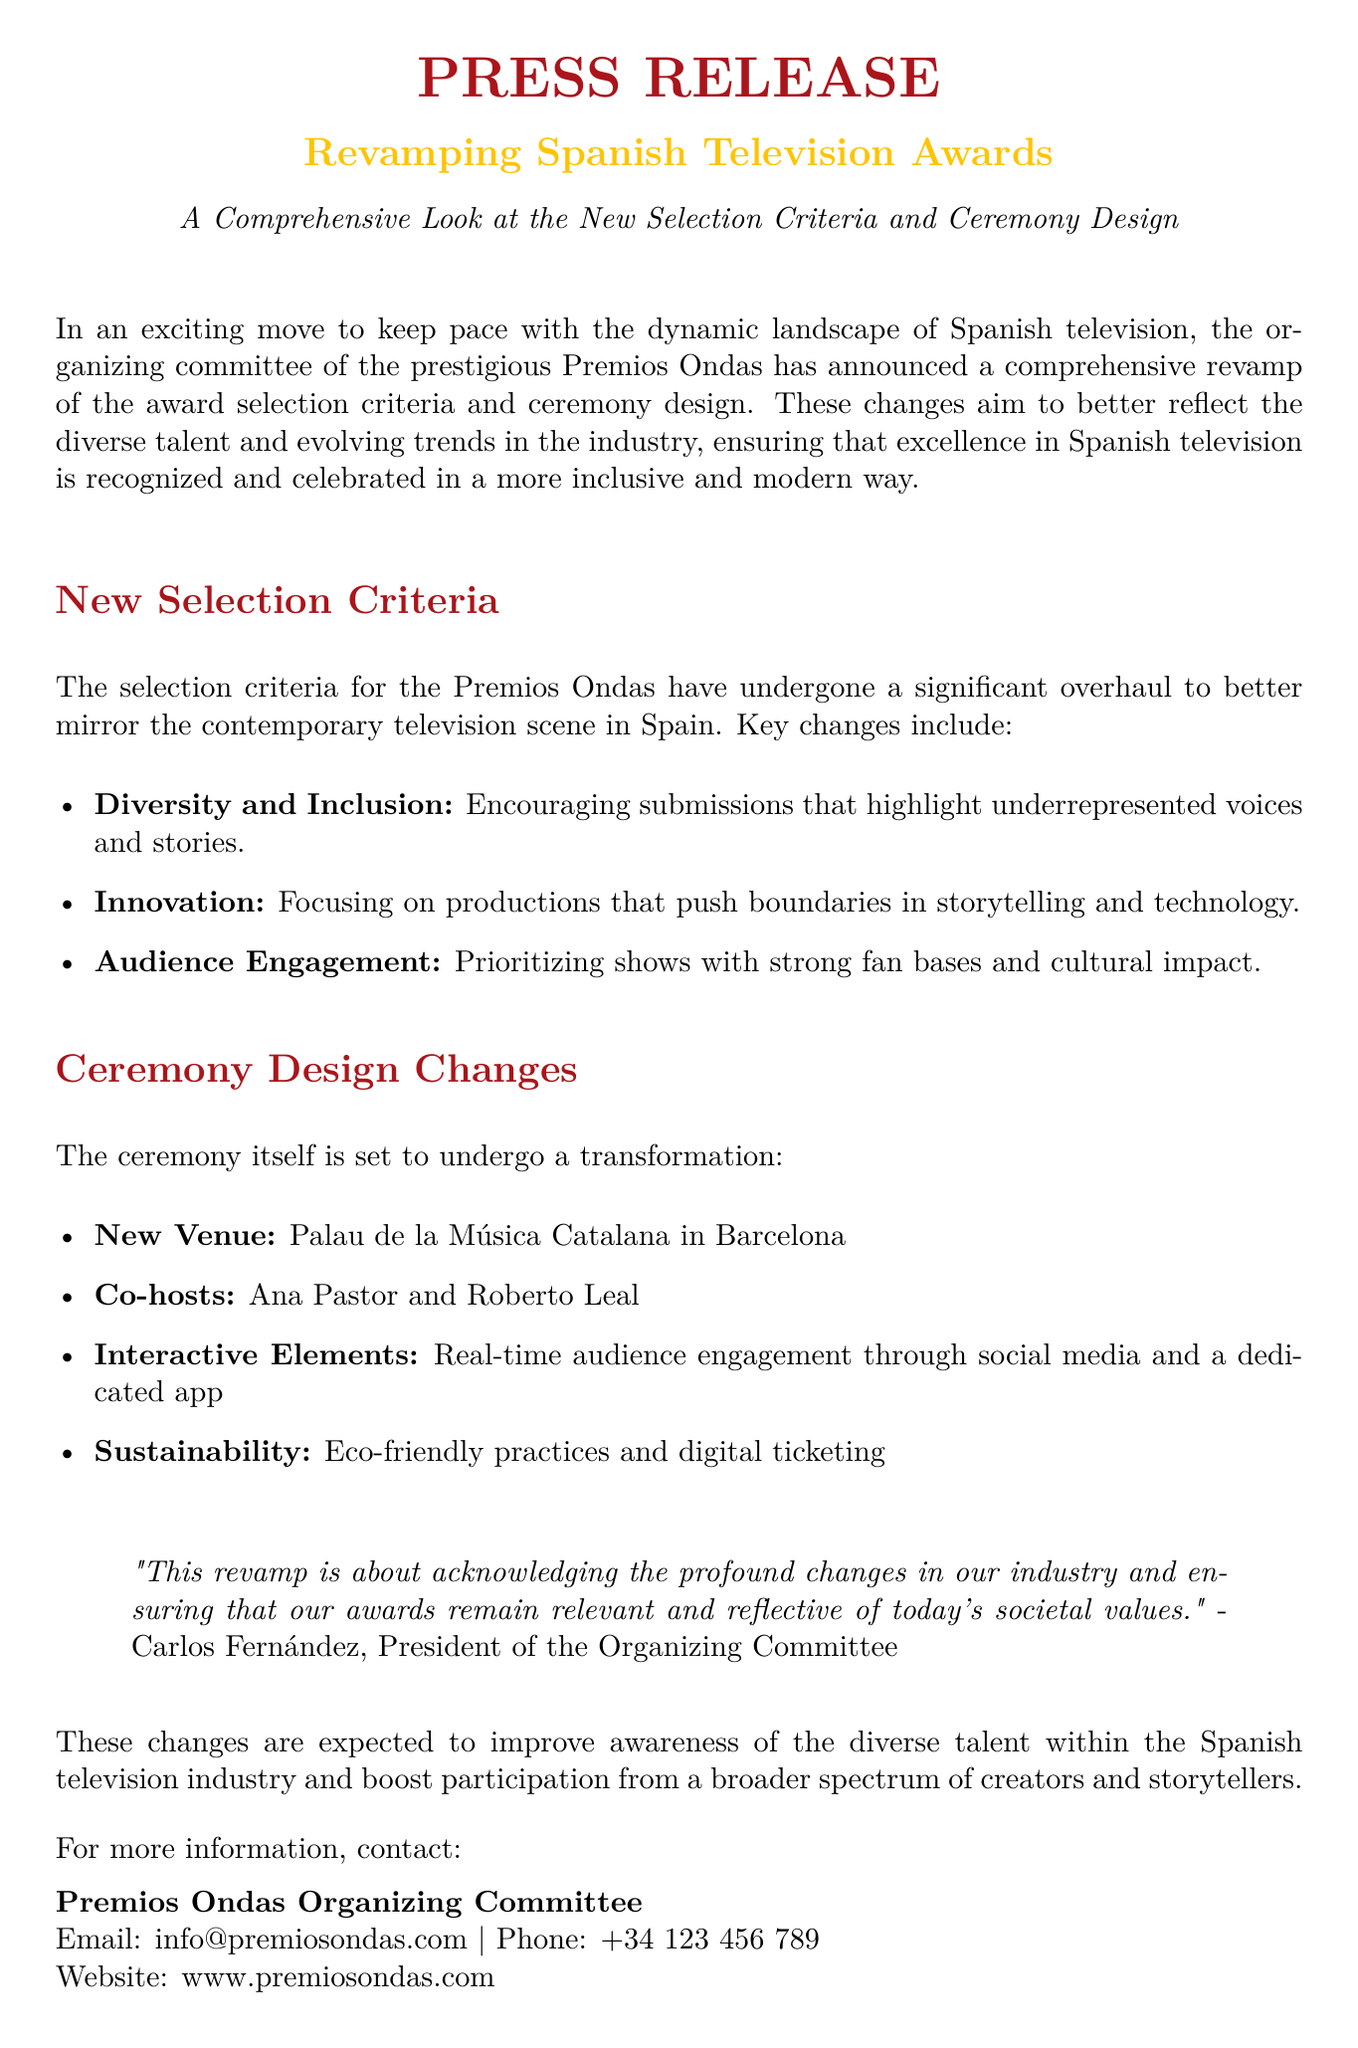what is the title of the press release? The title clearly states the main subject of the document.
Answer: Revamping Spanish Television Awards who are the co-hosts of the ceremony? The document lists the individuals who will be hosting the event.
Answer: Ana Pastor and Roberto Leal what is a key aspect of the new selection criteria? The document provides bullet points on what the new criteria focus on.
Answer: Diversity and Inclusion where will the ceremony take place? The location of the event is specified in the document.
Answer: Palau de la Música Catalana in Barcelona who is the President of the Organizing Committee? The document mentions the individual leading the committee.
Answer: Carlos Fernández what communication method is provided for more information? The document includes contact details for inquiries.
Answer: Email what is a new element introduced for audience engagement? The document lists new interactive components being integrated into the ceremony.
Answer: Real-time audience engagement through social media how will the awards promote sustainability? The document outlines the eco-friendly practices being adopted for the event.
Answer: Eco-friendly practices and digital ticketing what is the primary purpose of the revamp mentioned in the document? The document outlines the intention behind the changes to the awards.
Answer: Acknowledging profound changes in the industry 